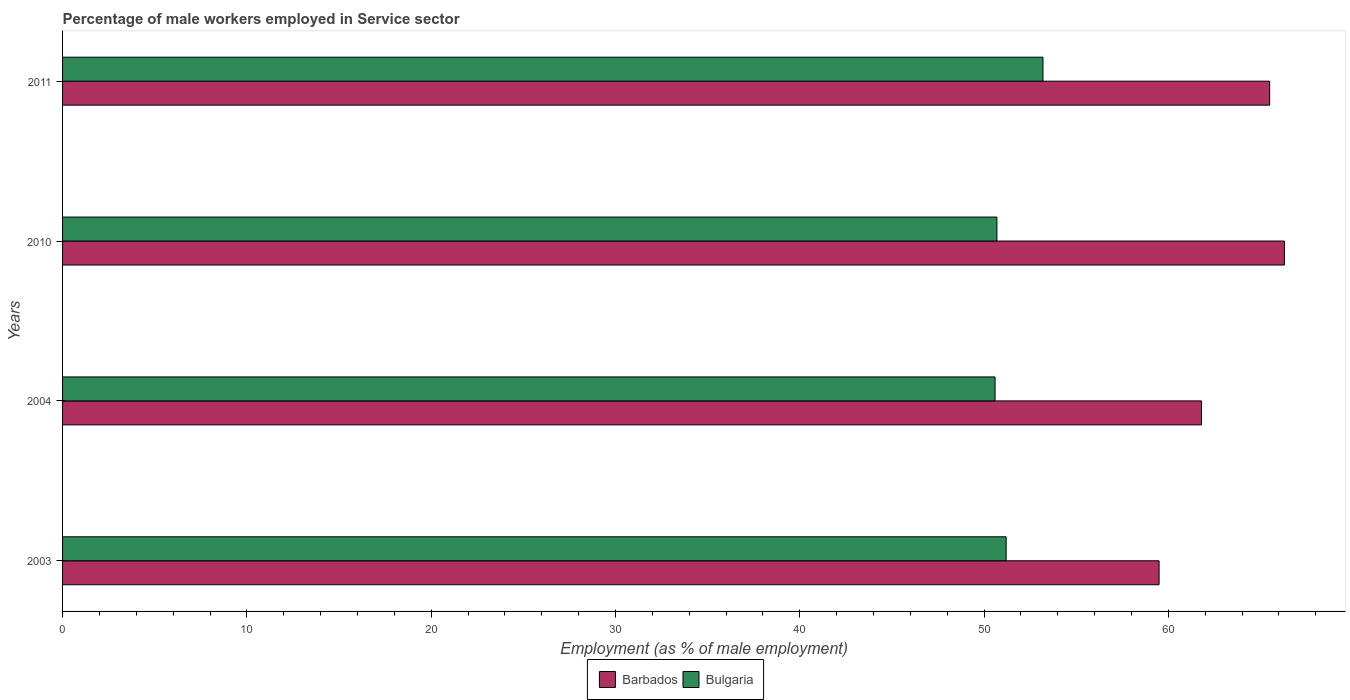Are the number of bars per tick equal to the number of legend labels?
Offer a terse response. Yes. Are the number of bars on each tick of the Y-axis equal?
Offer a terse response. Yes. What is the percentage of male workers employed in Service sector in Bulgaria in 2010?
Offer a very short reply. 50.7. Across all years, what is the maximum percentage of male workers employed in Service sector in Bulgaria?
Your answer should be compact. 53.2. Across all years, what is the minimum percentage of male workers employed in Service sector in Barbados?
Ensure brevity in your answer.  59.5. In which year was the percentage of male workers employed in Service sector in Barbados maximum?
Your answer should be very brief. 2010. In which year was the percentage of male workers employed in Service sector in Bulgaria minimum?
Your answer should be compact. 2004. What is the total percentage of male workers employed in Service sector in Bulgaria in the graph?
Give a very brief answer. 205.7. What is the difference between the percentage of male workers employed in Service sector in Barbados in 2003 and that in 2010?
Your answer should be very brief. -6.8. What is the difference between the percentage of male workers employed in Service sector in Bulgaria in 2004 and the percentage of male workers employed in Service sector in Barbados in 2003?
Offer a very short reply. -8.9. What is the average percentage of male workers employed in Service sector in Bulgaria per year?
Your answer should be compact. 51.43. In the year 2010, what is the difference between the percentage of male workers employed in Service sector in Bulgaria and percentage of male workers employed in Service sector in Barbados?
Keep it short and to the point. -15.6. What is the ratio of the percentage of male workers employed in Service sector in Barbados in 2003 to that in 2010?
Ensure brevity in your answer.  0.9. Is the percentage of male workers employed in Service sector in Barbados in 2003 less than that in 2010?
Your answer should be compact. Yes. Is the difference between the percentage of male workers employed in Service sector in Bulgaria in 2003 and 2004 greater than the difference between the percentage of male workers employed in Service sector in Barbados in 2003 and 2004?
Give a very brief answer. Yes. What is the difference between the highest and the second highest percentage of male workers employed in Service sector in Bulgaria?
Provide a succinct answer. 2. What is the difference between the highest and the lowest percentage of male workers employed in Service sector in Bulgaria?
Make the answer very short. 2.6. Is the sum of the percentage of male workers employed in Service sector in Barbados in 2003 and 2011 greater than the maximum percentage of male workers employed in Service sector in Bulgaria across all years?
Offer a very short reply. Yes. What does the 1st bar from the top in 2004 represents?
Provide a succinct answer. Bulgaria. What does the 1st bar from the bottom in 2004 represents?
Your response must be concise. Barbados. How many bars are there?
Give a very brief answer. 8. What is the difference between two consecutive major ticks on the X-axis?
Your answer should be very brief. 10. Does the graph contain any zero values?
Your answer should be compact. No. Where does the legend appear in the graph?
Your answer should be compact. Bottom center. What is the title of the graph?
Keep it short and to the point. Percentage of male workers employed in Service sector. What is the label or title of the X-axis?
Offer a very short reply. Employment (as % of male employment). What is the Employment (as % of male employment) of Barbados in 2003?
Offer a very short reply. 59.5. What is the Employment (as % of male employment) in Bulgaria in 2003?
Ensure brevity in your answer.  51.2. What is the Employment (as % of male employment) in Barbados in 2004?
Provide a short and direct response. 61.8. What is the Employment (as % of male employment) of Bulgaria in 2004?
Keep it short and to the point. 50.6. What is the Employment (as % of male employment) in Barbados in 2010?
Offer a very short reply. 66.3. What is the Employment (as % of male employment) in Bulgaria in 2010?
Provide a succinct answer. 50.7. What is the Employment (as % of male employment) in Barbados in 2011?
Provide a short and direct response. 65.5. What is the Employment (as % of male employment) of Bulgaria in 2011?
Your response must be concise. 53.2. Across all years, what is the maximum Employment (as % of male employment) in Barbados?
Your response must be concise. 66.3. Across all years, what is the maximum Employment (as % of male employment) in Bulgaria?
Offer a very short reply. 53.2. Across all years, what is the minimum Employment (as % of male employment) of Barbados?
Make the answer very short. 59.5. Across all years, what is the minimum Employment (as % of male employment) in Bulgaria?
Offer a terse response. 50.6. What is the total Employment (as % of male employment) in Barbados in the graph?
Make the answer very short. 253.1. What is the total Employment (as % of male employment) in Bulgaria in the graph?
Offer a terse response. 205.7. What is the difference between the Employment (as % of male employment) of Bulgaria in 2003 and that in 2004?
Offer a very short reply. 0.6. What is the difference between the Employment (as % of male employment) of Barbados in 2003 and that in 2010?
Make the answer very short. -6.8. What is the difference between the Employment (as % of male employment) of Bulgaria in 2003 and that in 2010?
Your answer should be very brief. 0.5. What is the difference between the Employment (as % of male employment) in Bulgaria in 2003 and that in 2011?
Your answer should be very brief. -2. What is the difference between the Employment (as % of male employment) in Barbados in 2004 and that in 2010?
Provide a succinct answer. -4.5. What is the difference between the Employment (as % of male employment) in Bulgaria in 2004 and that in 2010?
Your answer should be compact. -0.1. What is the difference between the Employment (as % of male employment) of Barbados in 2010 and that in 2011?
Your answer should be compact. 0.8. What is the difference between the Employment (as % of male employment) in Barbados in 2003 and the Employment (as % of male employment) in Bulgaria in 2004?
Provide a succinct answer. 8.9. What is the difference between the Employment (as % of male employment) in Barbados in 2003 and the Employment (as % of male employment) in Bulgaria in 2010?
Provide a succinct answer. 8.8. What is the difference between the Employment (as % of male employment) in Barbados in 2004 and the Employment (as % of male employment) in Bulgaria in 2011?
Offer a terse response. 8.6. What is the difference between the Employment (as % of male employment) of Barbados in 2010 and the Employment (as % of male employment) of Bulgaria in 2011?
Ensure brevity in your answer.  13.1. What is the average Employment (as % of male employment) in Barbados per year?
Your response must be concise. 63.27. What is the average Employment (as % of male employment) of Bulgaria per year?
Give a very brief answer. 51.42. In the year 2003, what is the difference between the Employment (as % of male employment) in Barbados and Employment (as % of male employment) in Bulgaria?
Provide a succinct answer. 8.3. In the year 2010, what is the difference between the Employment (as % of male employment) in Barbados and Employment (as % of male employment) in Bulgaria?
Offer a very short reply. 15.6. What is the ratio of the Employment (as % of male employment) of Barbados in 2003 to that in 2004?
Offer a very short reply. 0.96. What is the ratio of the Employment (as % of male employment) of Bulgaria in 2003 to that in 2004?
Keep it short and to the point. 1.01. What is the ratio of the Employment (as % of male employment) of Barbados in 2003 to that in 2010?
Keep it short and to the point. 0.9. What is the ratio of the Employment (as % of male employment) of Bulgaria in 2003 to that in 2010?
Offer a terse response. 1.01. What is the ratio of the Employment (as % of male employment) of Barbados in 2003 to that in 2011?
Make the answer very short. 0.91. What is the ratio of the Employment (as % of male employment) of Bulgaria in 2003 to that in 2011?
Your answer should be very brief. 0.96. What is the ratio of the Employment (as % of male employment) in Barbados in 2004 to that in 2010?
Your answer should be compact. 0.93. What is the ratio of the Employment (as % of male employment) in Bulgaria in 2004 to that in 2010?
Provide a short and direct response. 1. What is the ratio of the Employment (as % of male employment) of Barbados in 2004 to that in 2011?
Provide a succinct answer. 0.94. What is the ratio of the Employment (as % of male employment) in Bulgaria in 2004 to that in 2011?
Make the answer very short. 0.95. What is the ratio of the Employment (as % of male employment) of Barbados in 2010 to that in 2011?
Offer a terse response. 1.01. What is the ratio of the Employment (as % of male employment) in Bulgaria in 2010 to that in 2011?
Ensure brevity in your answer.  0.95. What is the difference between the highest and the second highest Employment (as % of male employment) of Barbados?
Make the answer very short. 0.8. 